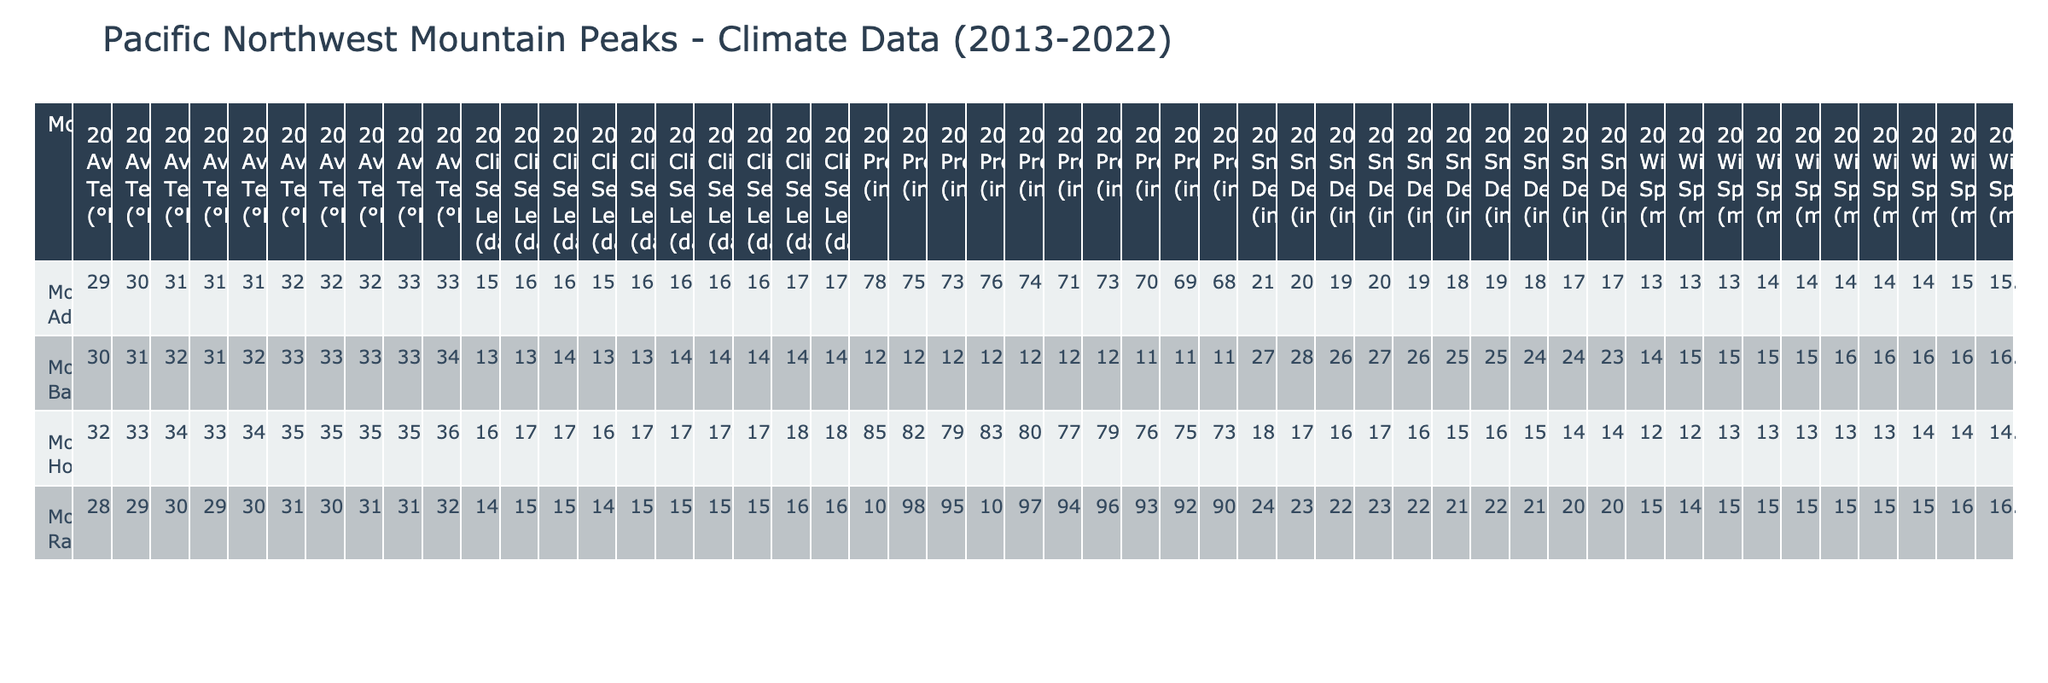What was the highest average temperature recorded for Mount Hood in the years presented? The highest average temperature for Mount Hood is found by checking each year’s data. Looking at the table, the highest average temperature is 36.2°F in 2022.
Answer: 36.2°F How much precipitation did Mount Baker receive on average over the decade? To find the average precipitation for Mount Baker, sum the annual precipitation amounts: (125.3 + 128.6 + 122.1 + 126.8 + 124.5 + 120.8 + 123.2 + 119.5 + 117.8 + 116.2) =  1,531.4 inches. There are 10 years, so the average is 1,531.4/10 = 153.14 inches.
Answer: 153.14 inches Did Mount Adams consistently receive less than 75 inches of snow depth each year over the decade? Checking the table, the snow depths for Mount Adams were 210, 205, 195, 200, 190, 185, 190, 175, and 170 inches from 2013 to 2022. None of these values are less than 75 inches, so the answer is no.
Answer: No Which mountain had the longest climbing season in 2019, and how long was it? Looking at the table for 2019, the climbing season lengths are as follows: Mount Rainier: 154 days, Mount Hood: 174 days, Mount Baker: 140 days, and Mount Adams: 164 days. The longest climbing season was 174 days for Mount Hood.
Answer: Mount Hood, 174 days What is the difference in average wind speed between Mount Rainier in 2021 and Mount Baker in 2020? To calculate the difference, find the wind speeds: Mount Rainier in 2021 was 16.1 mph and Mount Baker in 2020 was 16.3 mph. The difference is 16.3 - 16.1 = 0.2 mph.
Answer: 0.2 mph How many total days did the climbing season last for all mountains combined in 2022? Summing the climbing season lengths for 2022 gives: Mount Rainier: 162 days, Mount Hood: 182 days, Mount Baker: 149 days, Mount Adams: 172 days. Total = 162 + 182 + 149 + 172 = 665 days.
Answer: 665 days Was there a year where the average snowfall at Mount Rainier exceeded 240 inches? Checking the table for Mount Rainier’s snow depth across the years, it shows 240, 235, 220, 230, 225, 215, 220, 205 inches from 2013 to 2020. The maximum of 240 inches was recorded in 2013, so the answer is yes.
Answer: Yes Which mountain showed the least variability in average temperature over the presented years? By examining the average temperatures for each mountain, calculate the range for each. The smallest range indicates the least variability. Mount Adams ranges from 29.8°F to 33.4°F (3.6°F), which is the smallest.
Answer: Mount Adams 